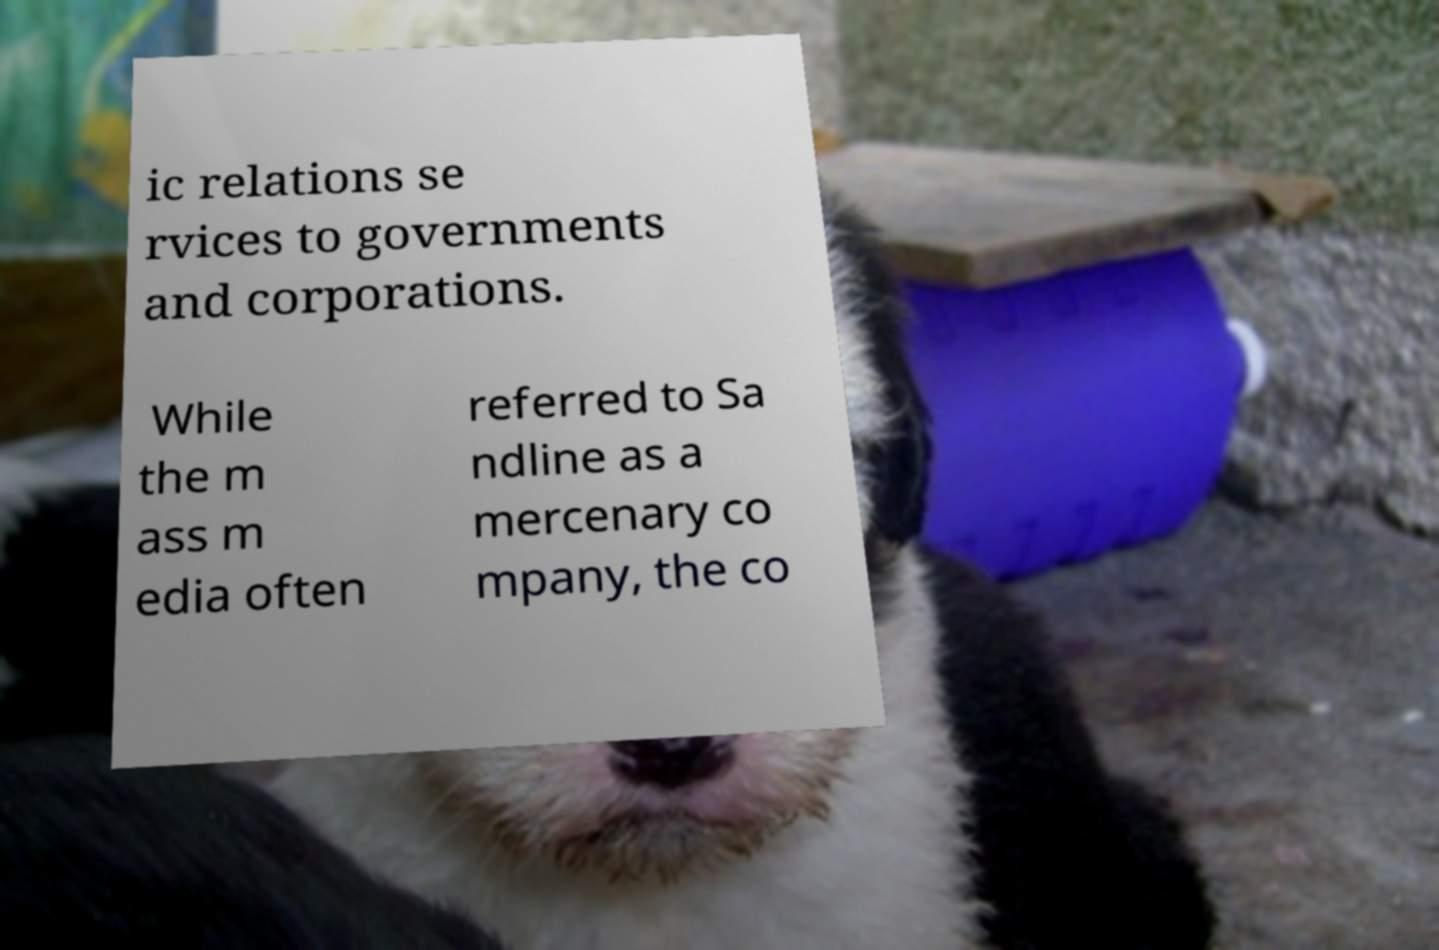Can you accurately transcribe the text from the provided image for me? ic relations se rvices to governments and corporations. While the m ass m edia often referred to Sa ndline as a mercenary co mpany, the co 